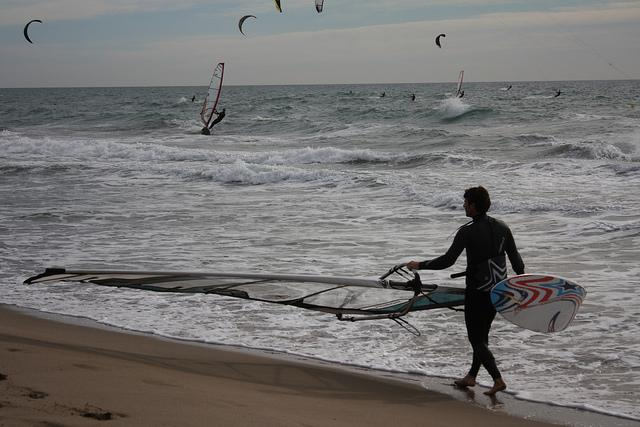What is the parachute called in paragliding? Please explain your reasoning. canopy. Canopy is the name. 